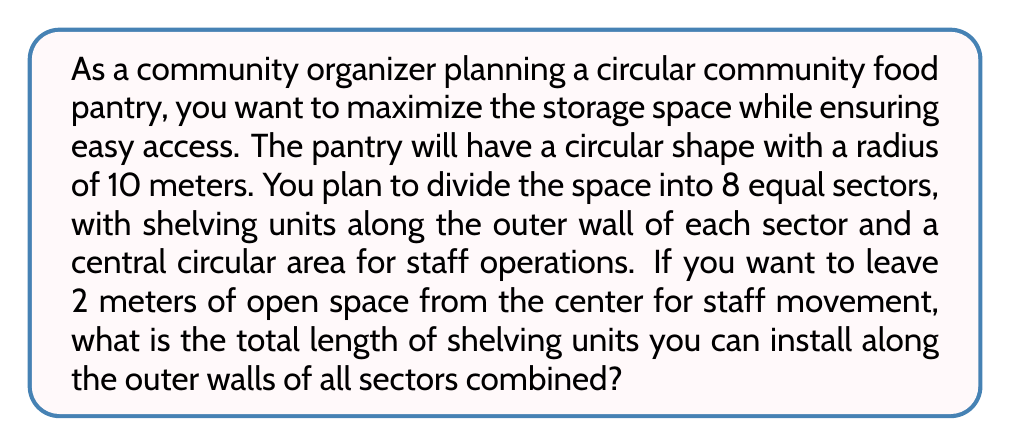Could you help me with this problem? Let's approach this step-by-step:

1) The pantry has a circular shape with a radius of 10 meters.

2) We need to leave 2 meters from the center for staff movement, so the shelving will start 2 meters from the center and extend to the outer wall.

3) The length of shelving in each sector will be an arc of a circle with radius 10 meters, minus the arc of a circle with radius 2 meters.

4) The formula for the length of an arc is:
   $$ L = r\theta $$
   where $L$ is the length of the arc, $r$ is the radius, and $\theta$ is the central angle in radians.

5) For 8 equal sectors, each sector will have a central angle of:
   $$ \theta = \frac{2\pi}{8} = \frac{\pi}{4} \text{ radians} $$

6) For the outer arc (radius 10 m):
   $$ L_{\text{outer}} = 10 \cdot \frac{\pi}{4} = \frac{5\pi}{2} \text{ meters} $$

7) For the inner arc (radius 2 m):
   $$ L_{\text{inner}} = 2 \cdot \frac{\pi}{4} = \frac{\pi}{2} \text{ meters} $$

8) The length of shelving for one sector is:
   $$ L_{\text{sector}} = L_{\text{outer}} - L_{\text{inner}} = \frac{5\pi}{2} - \frac{\pi}{2} = 2\pi \text{ meters} $$

9) For all 8 sectors, the total length is:
   $$ L_{\text{total}} = 8 \cdot 2\pi = 16\pi \text{ meters} $$

[asy]
size(200);
draw(circle((0,0),10));
draw(circle((0,0),2));
for(int i=0; i<8; ++i) {
  draw((0,0)--dir(45*i)*10);
}
label("10m", (5,0), E);
label("2m", (1,0), E);
[/asy]
Answer: The total length of shelving units that can be installed is $16\pi \approx 50.27$ meters. 